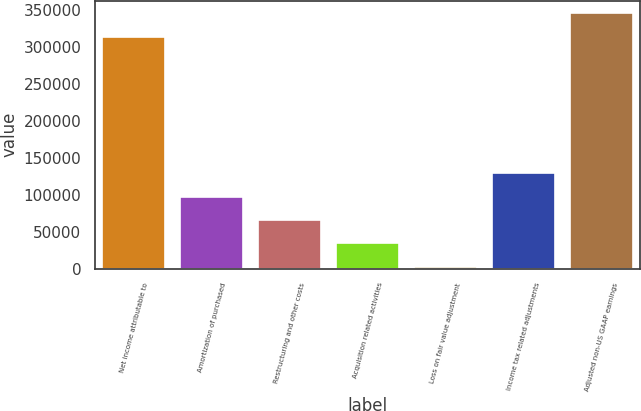Convert chart to OTSL. <chart><loc_0><loc_0><loc_500><loc_500><bar_chart><fcel>Net income attributable to<fcel>Amortization of purchased<fcel>Restructuring and other costs<fcel>Acquisition related activities<fcel>Loss on fair value adjustment<fcel>Income tax related adjustments<fcel>Adjusted non-US GAAP earnings<nl><fcel>314213<fcel>97811.3<fcel>66183.2<fcel>34555.1<fcel>2927<fcel>129439<fcel>345841<nl></chart> 